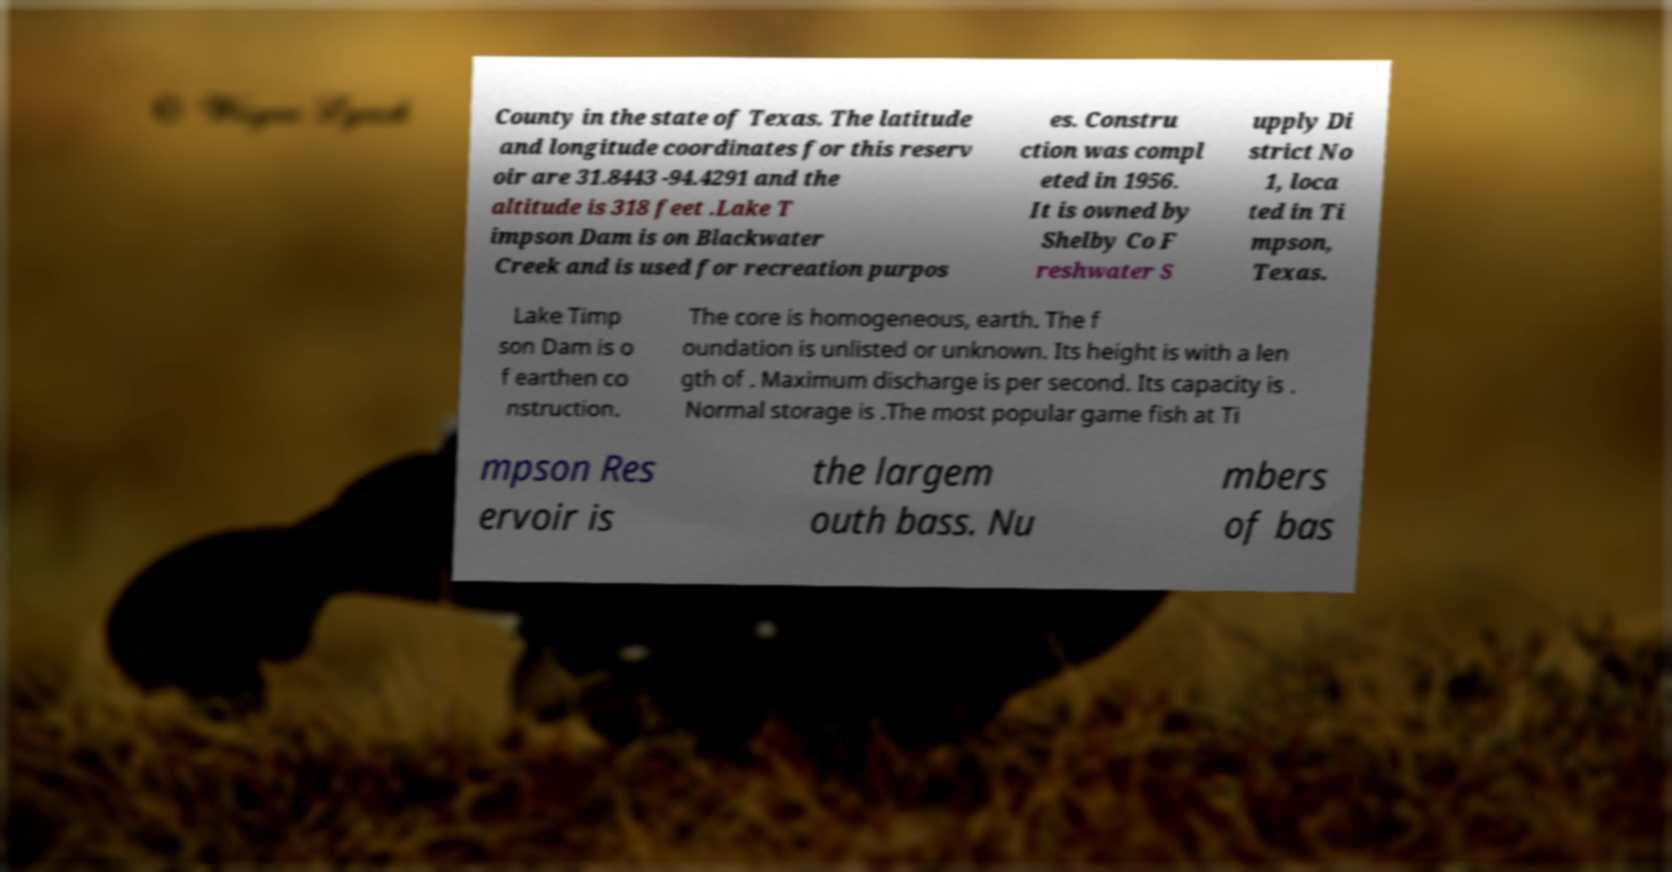Please read and relay the text visible in this image. What does it say? County in the state of Texas. The latitude and longitude coordinates for this reserv oir are 31.8443 -94.4291 and the altitude is 318 feet .Lake T impson Dam is on Blackwater Creek and is used for recreation purpos es. Constru ction was compl eted in 1956. It is owned by Shelby Co F reshwater S upply Di strict No 1, loca ted in Ti mpson, Texas. Lake Timp son Dam is o f earthen co nstruction. The core is homogeneous, earth. The f oundation is unlisted or unknown. Its height is with a len gth of . Maximum discharge is per second. Its capacity is . Normal storage is .The most popular game fish at Ti mpson Res ervoir is the largem outh bass. Nu mbers of bas 